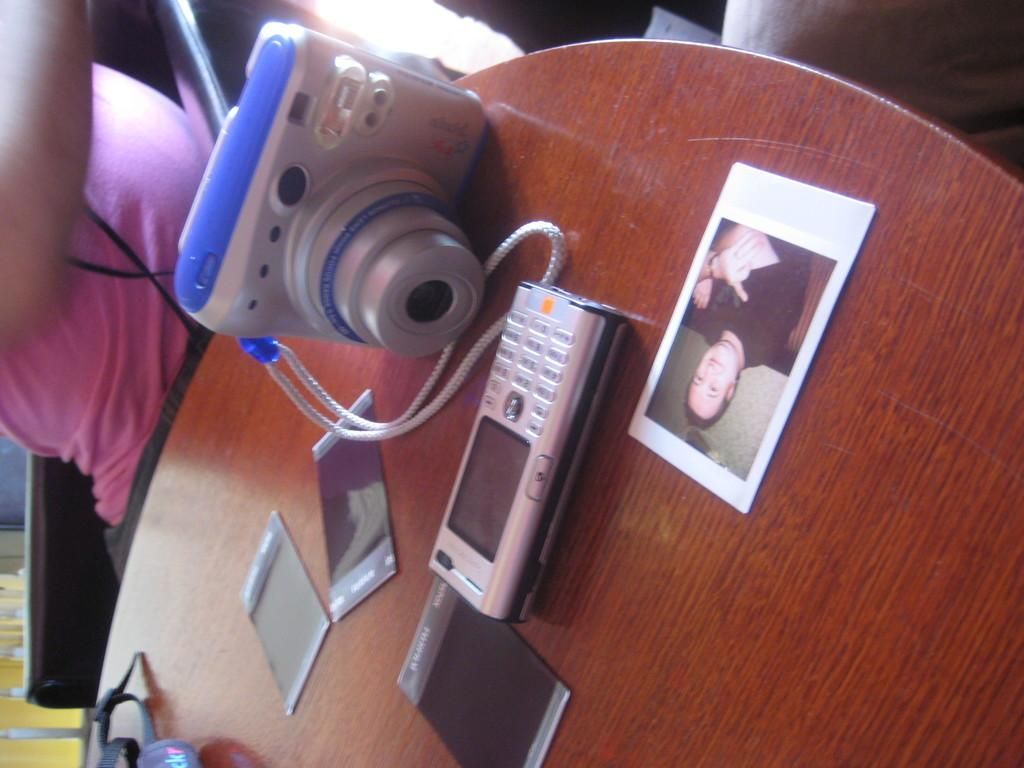What is the color of the table in the image? The table in the image is brown. What is placed on the table? There is a photo, a camera, a phone, and other black color things on the table. What is the person in the image wearing? The person in the image is wearing a pink dress. Can you hear the noise coming from the harbor in the image? There is no harbor or noise present in the image; it only features a brown table, objects on the table, and a person in a pink dress. 